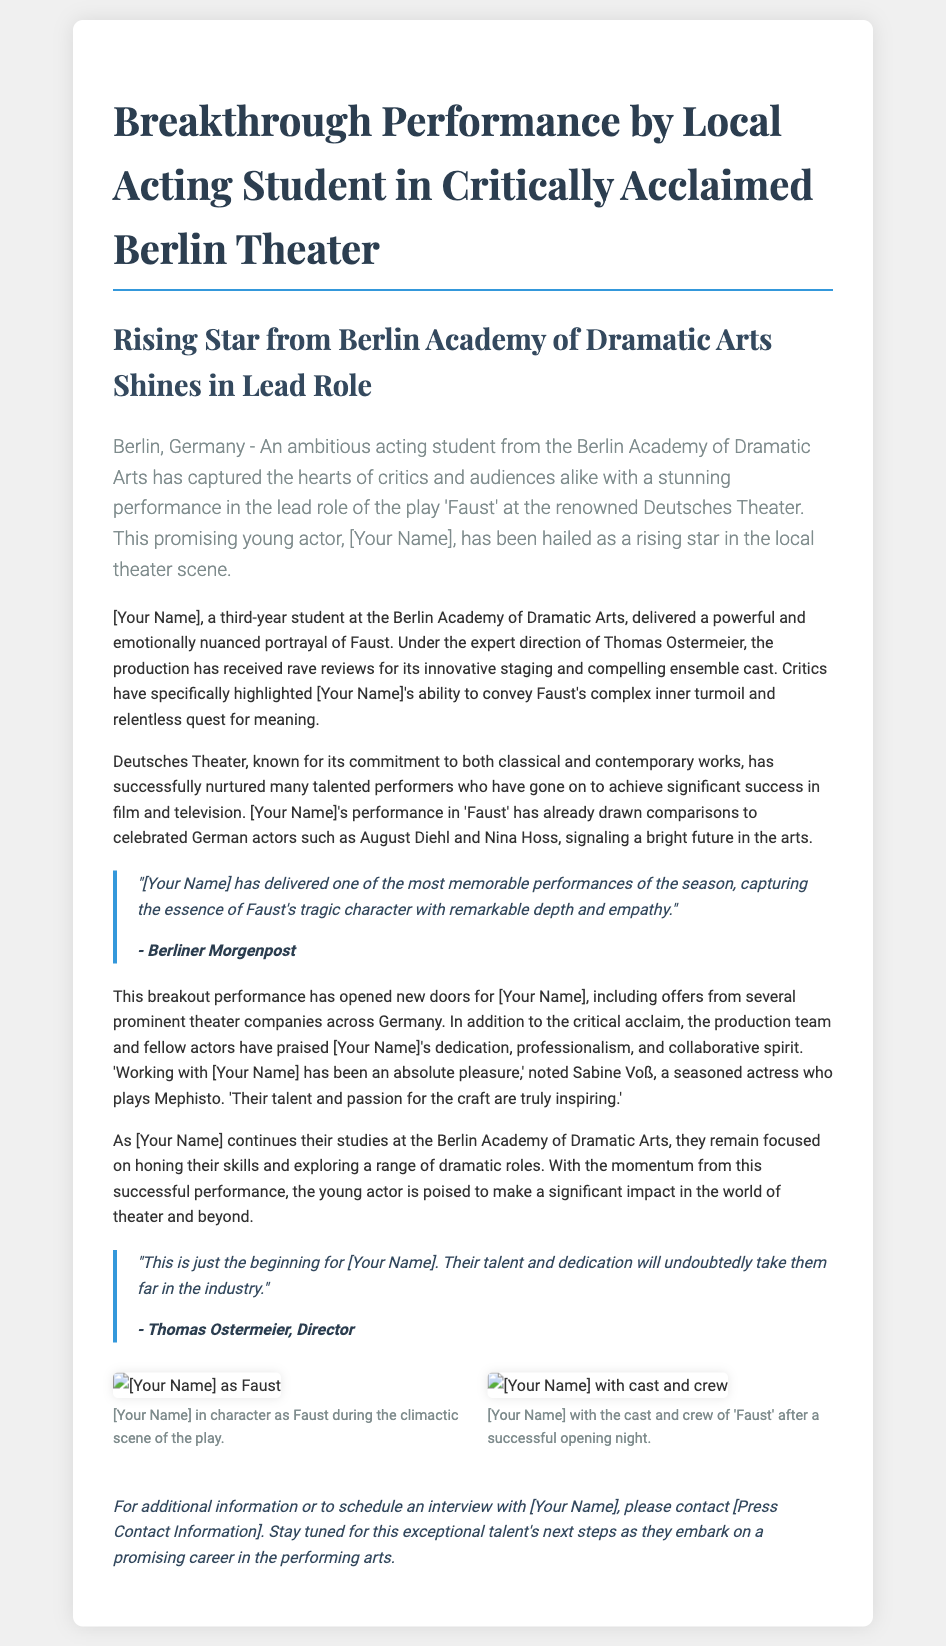What is the name of the play featured in the performance? The name of the play is explicitly mentioned in the document as 'Faust'.
Answer: Faust Who is the director of the production? The director's name is given in the document. His name is Thomas Ostermeier.
Answer: Thomas Ostermeier How many years has [Your Name] been studying at the Berlin Academy of Dramatic Arts? The document states that [Your Name] is a third-year student, indicating how long they have been studying.
Answer: Three years Which theater is hosting the performance? The specific name of the theater is mentioned in the document, which is Deutsches Theater.
Answer: Deutsches Theater What character did [Your Name] portray in the play? The document clearly states that [Your Name] portrayed the character of Faust.
Answer: Faust What type of offers has [Your Name] received as a result of the performance? The document details that [Your Name] has received offers from several prominent theater companies.
Answer: Offers from theater companies Who praised [Your Name]'s dedication and collaborative spirit? The document quotes Sabine Voß, a seasoned actress, who praised [Your Name].
Answer: Sabine Voß How has the Berlin Academy of Dramatic Arts contributed to [Your Name]'s career? The document suggests that the academy has nurtured many talented performers, indicating a supportive environment.
Answer: Nurtured talent What is the overall sentiment of the reviews about [Your Name]'s performance? The document states that the performance has received rave reviews, indicating a positive reception.
Answer: Rave reviews 